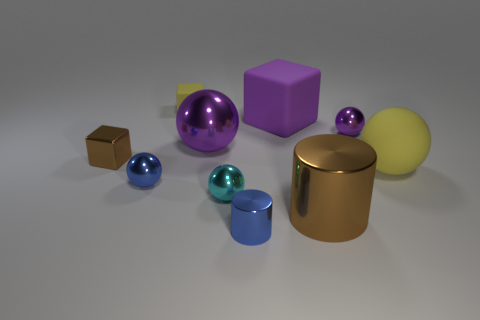There is a yellow object that is left of the yellow rubber sphere; is it the same size as the purple matte thing to the left of the large metal cylinder?
Your answer should be compact. No. The tiny metallic ball right of the cyan metallic sphere is what color?
Make the answer very short. Purple. There is a small sphere that is the same color as the big metallic sphere; what is its material?
Your answer should be very brief. Metal. What number of rubber blocks have the same color as the matte sphere?
Offer a very short reply. 1. There is a blue metal cylinder; is it the same size as the blue thing that is behind the small cyan metal sphere?
Keep it short and to the point. Yes. What size is the yellow thing that is behind the tiny purple shiny ball behind the small cube that is on the left side of the yellow rubber cube?
Keep it short and to the point. Small. There is a cyan ball; how many tiny metallic things are behind it?
Give a very brief answer. 3. There is a small blue thing that is behind the brown metallic thing that is on the right side of the small brown block; what is its material?
Your response must be concise. Metal. Do the blue shiny cylinder and the brown cylinder have the same size?
Your answer should be very brief. No. What number of things are either tiny shiny cylinders that are in front of the tiny yellow matte block or purple spheres left of the big matte cube?
Offer a very short reply. 2. 